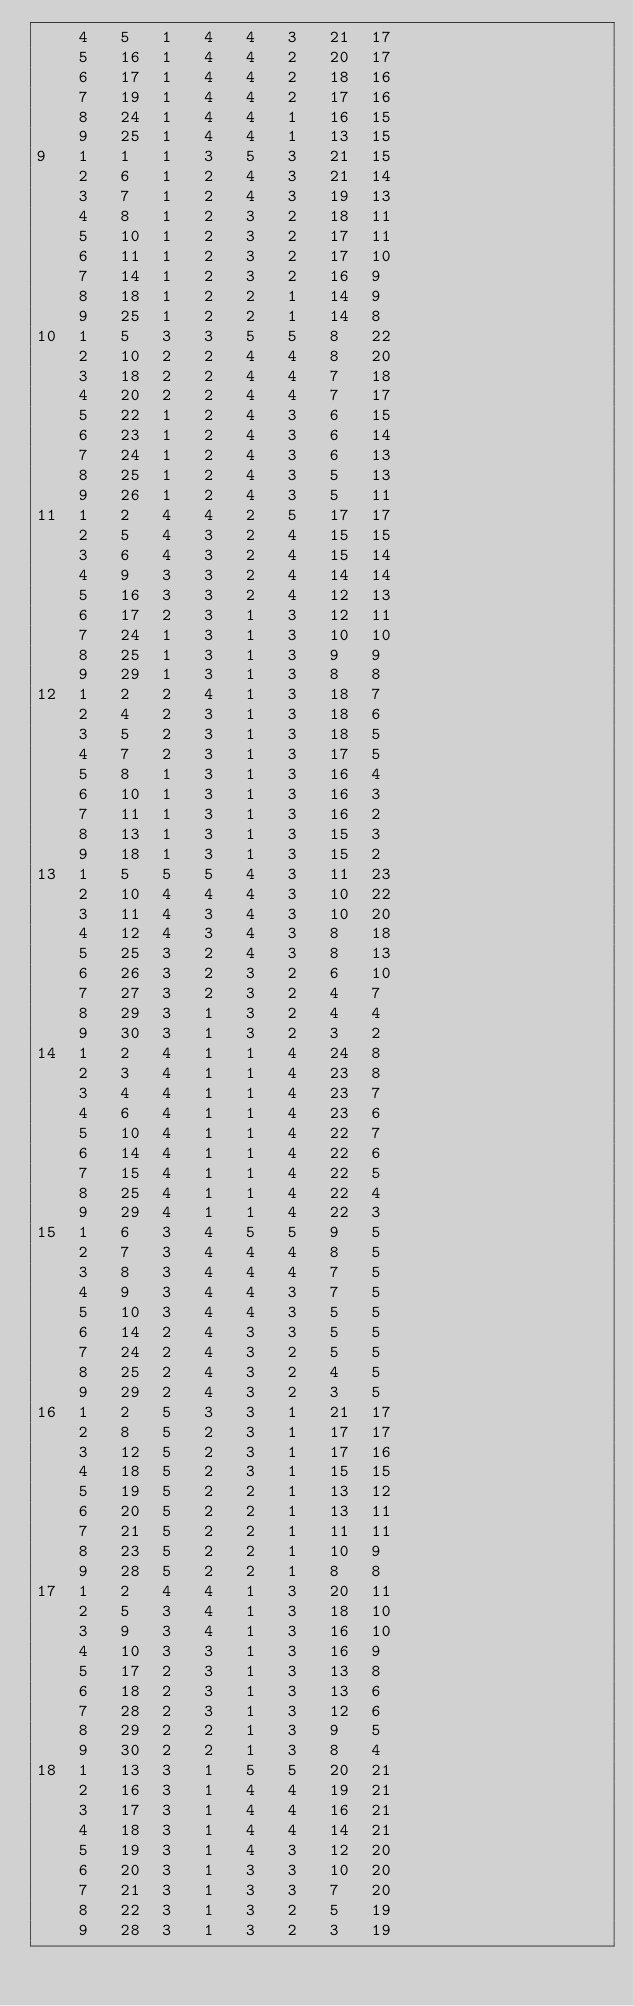Convert code to text. <code><loc_0><loc_0><loc_500><loc_500><_ObjectiveC_>	4	5	1	4	4	3	21	17	
	5	16	1	4	4	2	20	17	
	6	17	1	4	4	2	18	16	
	7	19	1	4	4	2	17	16	
	8	24	1	4	4	1	16	15	
	9	25	1	4	4	1	13	15	
9	1	1	1	3	5	3	21	15	
	2	6	1	2	4	3	21	14	
	3	7	1	2	4	3	19	13	
	4	8	1	2	3	2	18	11	
	5	10	1	2	3	2	17	11	
	6	11	1	2	3	2	17	10	
	7	14	1	2	3	2	16	9	
	8	18	1	2	2	1	14	9	
	9	25	1	2	2	1	14	8	
10	1	5	3	3	5	5	8	22	
	2	10	2	2	4	4	8	20	
	3	18	2	2	4	4	7	18	
	4	20	2	2	4	4	7	17	
	5	22	1	2	4	3	6	15	
	6	23	1	2	4	3	6	14	
	7	24	1	2	4	3	6	13	
	8	25	1	2	4	3	5	13	
	9	26	1	2	4	3	5	11	
11	1	2	4	4	2	5	17	17	
	2	5	4	3	2	4	15	15	
	3	6	4	3	2	4	15	14	
	4	9	3	3	2	4	14	14	
	5	16	3	3	2	4	12	13	
	6	17	2	3	1	3	12	11	
	7	24	1	3	1	3	10	10	
	8	25	1	3	1	3	9	9	
	9	29	1	3	1	3	8	8	
12	1	2	2	4	1	3	18	7	
	2	4	2	3	1	3	18	6	
	3	5	2	3	1	3	18	5	
	4	7	2	3	1	3	17	5	
	5	8	1	3	1	3	16	4	
	6	10	1	3	1	3	16	3	
	7	11	1	3	1	3	16	2	
	8	13	1	3	1	3	15	3	
	9	18	1	3	1	3	15	2	
13	1	5	5	5	4	3	11	23	
	2	10	4	4	4	3	10	22	
	3	11	4	3	4	3	10	20	
	4	12	4	3	4	3	8	18	
	5	25	3	2	4	3	8	13	
	6	26	3	2	3	2	6	10	
	7	27	3	2	3	2	4	7	
	8	29	3	1	3	2	4	4	
	9	30	3	1	3	2	3	2	
14	1	2	4	1	1	4	24	8	
	2	3	4	1	1	4	23	8	
	3	4	4	1	1	4	23	7	
	4	6	4	1	1	4	23	6	
	5	10	4	1	1	4	22	7	
	6	14	4	1	1	4	22	6	
	7	15	4	1	1	4	22	5	
	8	25	4	1	1	4	22	4	
	9	29	4	1	1	4	22	3	
15	1	6	3	4	5	5	9	5	
	2	7	3	4	4	4	8	5	
	3	8	3	4	4	4	7	5	
	4	9	3	4	4	3	7	5	
	5	10	3	4	4	3	5	5	
	6	14	2	4	3	3	5	5	
	7	24	2	4	3	2	5	5	
	8	25	2	4	3	2	4	5	
	9	29	2	4	3	2	3	5	
16	1	2	5	3	3	1	21	17	
	2	8	5	2	3	1	17	17	
	3	12	5	2	3	1	17	16	
	4	18	5	2	3	1	15	15	
	5	19	5	2	2	1	13	12	
	6	20	5	2	2	1	13	11	
	7	21	5	2	2	1	11	11	
	8	23	5	2	2	1	10	9	
	9	28	5	2	2	1	8	8	
17	1	2	4	4	1	3	20	11	
	2	5	3	4	1	3	18	10	
	3	9	3	4	1	3	16	10	
	4	10	3	3	1	3	16	9	
	5	17	2	3	1	3	13	8	
	6	18	2	3	1	3	13	6	
	7	28	2	3	1	3	12	6	
	8	29	2	2	1	3	9	5	
	9	30	2	2	1	3	8	4	
18	1	13	3	1	5	5	20	21	
	2	16	3	1	4	4	19	21	
	3	17	3	1	4	4	16	21	
	4	18	3	1	4	4	14	21	
	5	19	3	1	4	3	12	20	
	6	20	3	1	3	3	10	20	
	7	21	3	1	3	3	7	20	
	8	22	3	1	3	2	5	19	
	9	28	3	1	3	2	3	19	</code> 